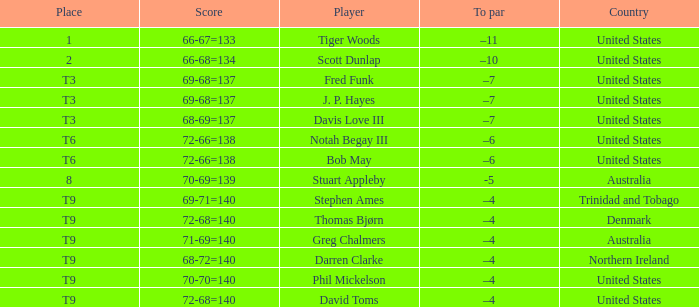What place did Bob May get when his score was 72-66=138? T6. 